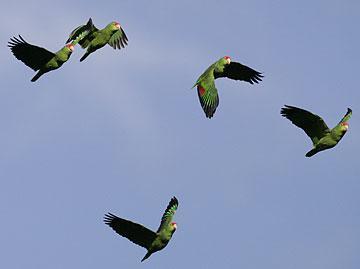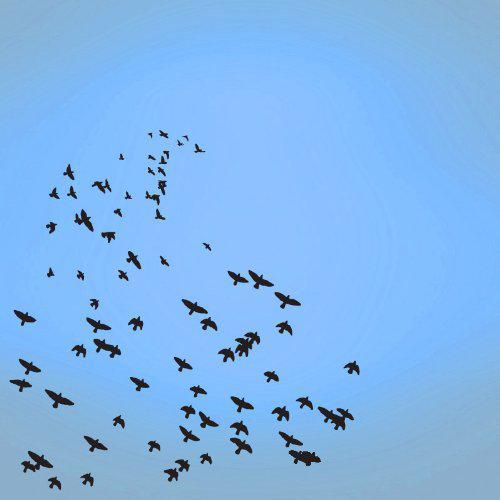The first image is the image on the left, the second image is the image on the right. For the images shown, is this caption "The left photo depicts only two parrots." true? Answer yes or no. No. The first image is the image on the left, the second image is the image on the right. Analyze the images presented: Is the assertion "Two birds are flying the air in the image on the left" valid? Answer yes or no. No. 